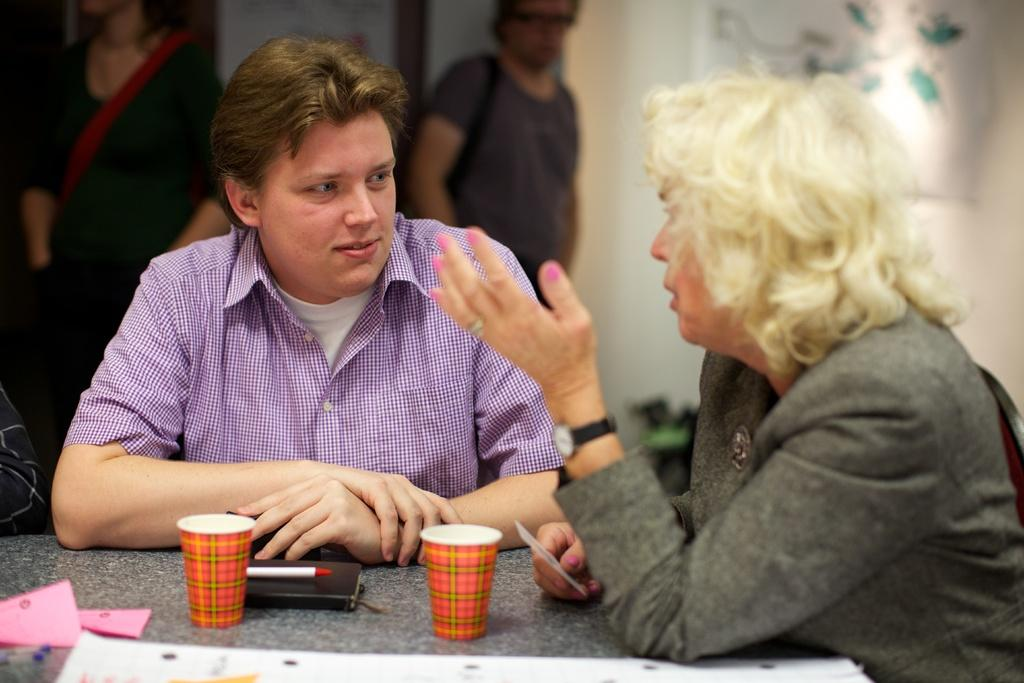How many people are sitting in the image? There are two persons sitting in the image. What objects are in front of the sitting persons? There is a book, a pen, and two glasses in front of the sitting persons. What can be seen in the background of the image? There are two persons standing in the background of the image. What type of cabbage is being used as a tablecloth in the image? There is no cabbage present in the image, and it is not being used as a tablecloth. What drug is being discussed by the persons in the image? There is no mention or indication of any drug in the image. 